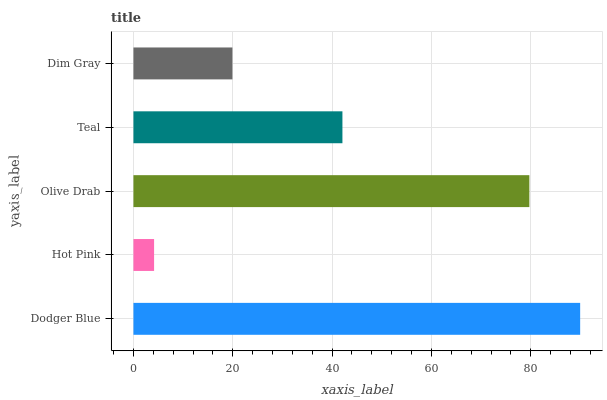Is Hot Pink the minimum?
Answer yes or no. Yes. Is Dodger Blue the maximum?
Answer yes or no. Yes. Is Olive Drab the minimum?
Answer yes or no. No. Is Olive Drab the maximum?
Answer yes or no. No. Is Olive Drab greater than Hot Pink?
Answer yes or no. Yes. Is Hot Pink less than Olive Drab?
Answer yes or no. Yes. Is Hot Pink greater than Olive Drab?
Answer yes or no. No. Is Olive Drab less than Hot Pink?
Answer yes or no. No. Is Teal the high median?
Answer yes or no. Yes. Is Teal the low median?
Answer yes or no. Yes. Is Dodger Blue the high median?
Answer yes or no. No. Is Olive Drab the low median?
Answer yes or no. No. 